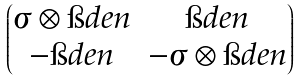<formula> <loc_0><loc_0><loc_500><loc_500>\begin{pmatrix} \sigma \otimes \i d e n & \i d e n \\ - \i d e n & - \sigma \otimes \i d e n \end{pmatrix}</formula> 